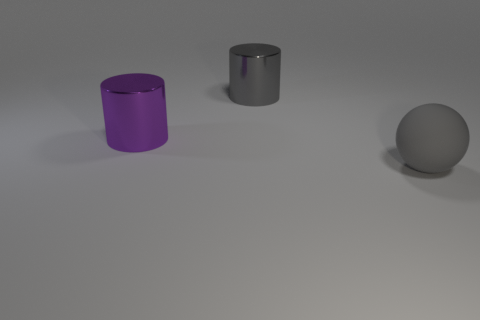Is there anything else that is made of the same material as the big gray ball?
Your answer should be very brief. No. There is a cylinder behind the large purple metallic cylinder; how big is it?
Your response must be concise. Large. What color is the big thing that is behind the gray rubber thing and on the right side of the purple shiny thing?
Your answer should be compact. Gray. Do the gray object that is left of the gray matte sphere and the big ball have the same size?
Keep it short and to the point. Yes. Is there a large purple cylinder on the left side of the object that is left of the large gray metal object?
Make the answer very short. No. What is the gray sphere made of?
Provide a short and direct response. Rubber. There is a matte ball; are there any metal things in front of it?
Your response must be concise. No. What size is the purple object that is the same shape as the big gray metallic thing?
Give a very brief answer. Large. Is the number of gray matte things left of the sphere the same as the number of purple shiny things to the left of the big purple shiny cylinder?
Keep it short and to the point. Yes. How many purple shiny objects are there?
Offer a terse response. 1. 